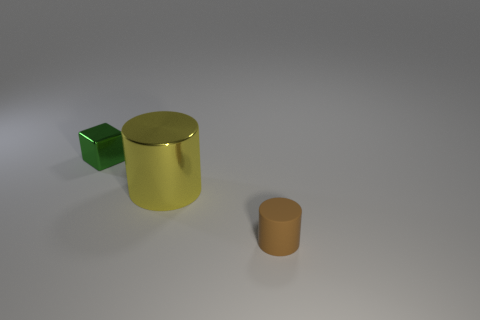Add 2 big gray rubber blocks. How many objects exist? 5 Subtract all cylinders. How many objects are left? 1 Subtract 1 yellow cylinders. How many objects are left? 2 Subtract all cyan matte blocks. Subtract all large cylinders. How many objects are left? 2 Add 3 tiny rubber cylinders. How many tiny rubber cylinders are left? 4 Add 1 green shiny objects. How many green shiny objects exist? 2 